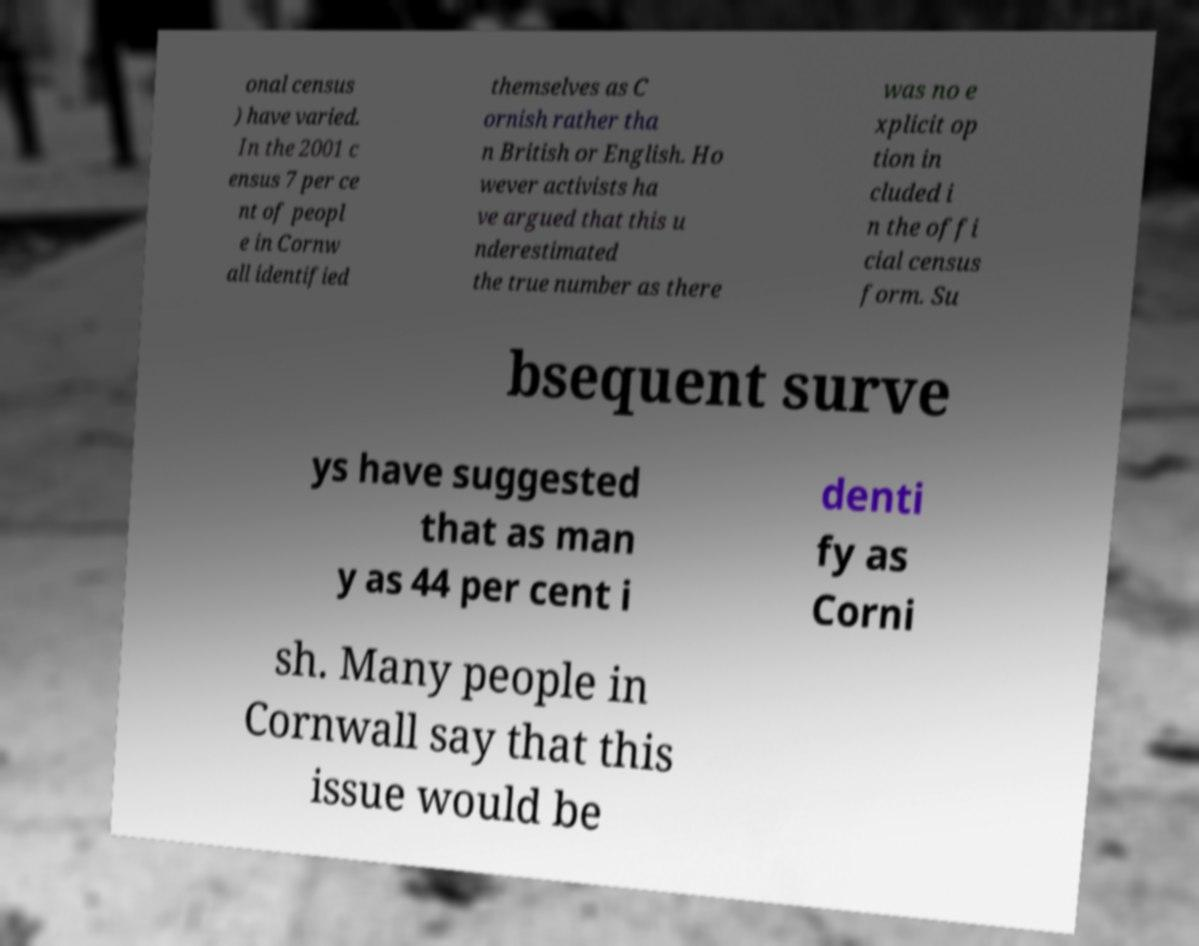Could you assist in decoding the text presented in this image and type it out clearly? onal census ) have varied. In the 2001 c ensus 7 per ce nt of peopl e in Cornw all identified themselves as C ornish rather tha n British or English. Ho wever activists ha ve argued that this u nderestimated the true number as there was no e xplicit op tion in cluded i n the offi cial census form. Su bsequent surve ys have suggested that as man y as 44 per cent i denti fy as Corni sh. Many people in Cornwall say that this issue would be 